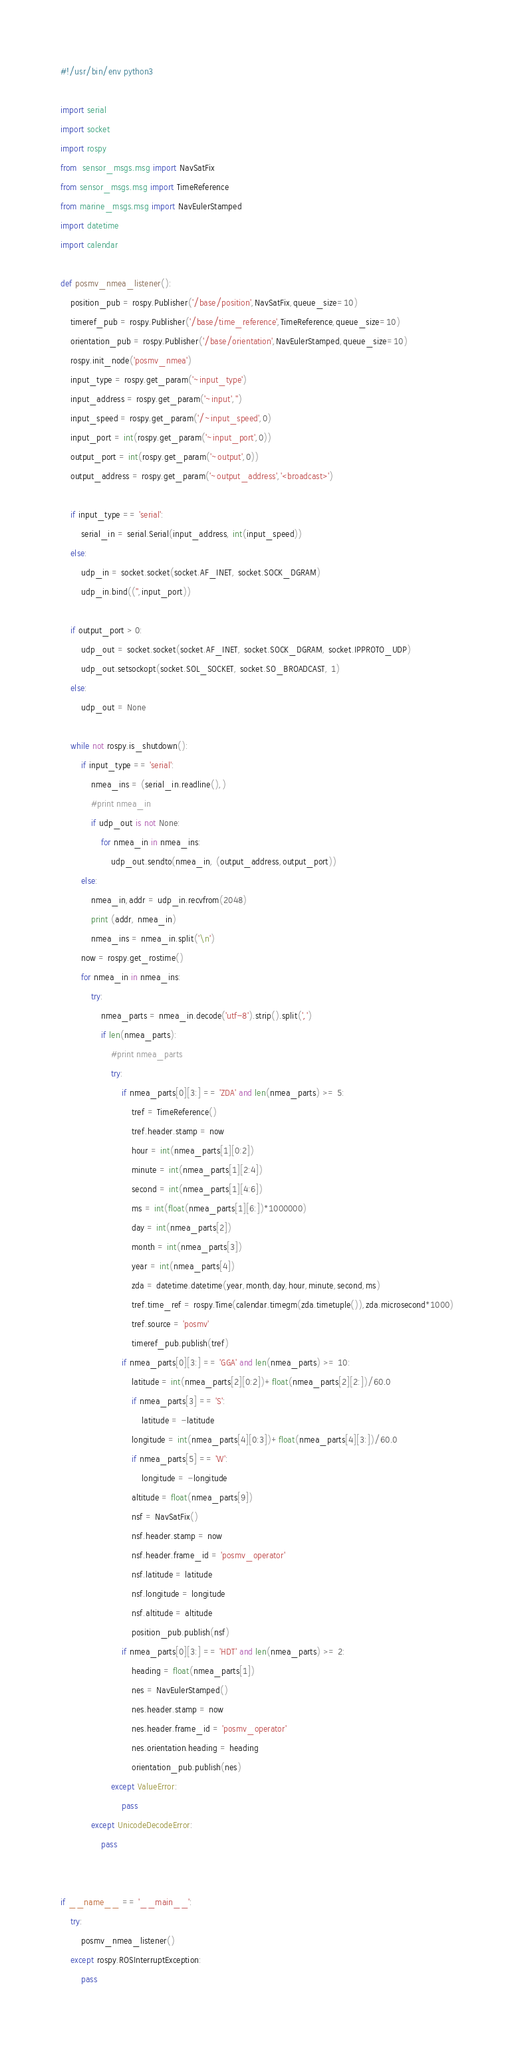Convert code to text. <code><loc_0><loc_0><loc_500><loc_500><_Python_>#!/usr/bin/env python3

import serial
import socket
import rospy
from  sensor_msgs.msg import NavSatFix
from sensor_msgs.msg import TimeReference
from marine_msgs.msg import NavEulerStamped
import datetime
import calendar

def posmv_nmea_listener():
    position_pub = rospy.Publisher('/base/position',NavSatFix,queue_size=10)
    timeref_pub = rospy.Publisher('/base/time_reference',TimeReference,queue_size=10)
    orientation_pub = rospy.Publisher('/base/orientation',NavEulerStamped,queue_size=10)
    rospy.init_node('posmv_nmea')
    input_type = rospy.get_param('~input_type')
    input_address = rospy.get_param('~input','')
    input_speed = rospy.get_param('/~input_speed',0)
    input_port = int(rospy.get_param('~input_port',0))
    output_port = int(rospy.get_param('~output',0))
    output_address = rospy.get_param('~output_address','<broadcast>')
    
    if input_type == 'serial':
        serial_in = serial.Serial(input_address, int(input_speed))
    else:
        udp_in = socket.socket(socket.AF_INET, socket.SOCK_DGRAM)
        udp_in.bind(('',input_port))
    
    if output_port > 0:
        udp_out = socket.socket(socket.AF_INET, socket.SOCK_DGRAM, socket.IPPROTO_UDP)
        udp_out.setsockopt(socket.SOL_SOCKET, socket.SO_BROADCAST, 1)
    else:
        udp_out = None
            
    while not rospy.is_shutdown():
        if input_type == 'serial':
            nmea_ins = (serial_in.readline(),)
            #print nmea_in
            if udp_out is not None:
                for nmea_in in nmea_ins:
                    udp_out.sendto(nmea_in, (output_address,output_port))
        else:
            nmea_in,addr = udp_in.recvfrom(2048)
            print (addr, nmea_in)
            nmea_ins = nmea_in.split('\n')
        now = rospy.get_rostime()
        for nmea_in in nmea_ins:
            try:
                nmea_parts = nmea_in.decode('utf-8').strip().split(',')
                if len(nmea_parts):
                    #print nmea_parts
                    try:
                        if nmea_parts[0][3:] == 'ZDA' and len(nmea_parts) >= 5:
                            tref = TimeReference()
                            tref.header.stamp = now
                            hour = int(nmea_parts[1][0:2])
                            minute = int(nmea_parts[1][2:4])
                            second = int(nmea_parts[1][4:6])
                            ms = int(float(nmea_parts[1][6:])*1000000)
                            day = int(nmea_parts[2])
                            month = int(nmea_parts[3])
                            year = int(nmea_parts[4])
                            zda = datetime.datetime(year,month,day,hour,minute,second,ms)
                            tref.time_ref = rospy.Time(calendar.timegm(zda.timetuple()),zda.microsecond*1000)
                            tref.source = 'posmv'
                            timeref_pub.publish(tref)
                        if nmea_parts[0][3:] == 'GGA' and len(nmea_parts) >= 10:
                            latitude = int(nmea_parts[2][0:2])+float(nmea_parts[2][2:])/60.0
                            if nmea_parts[3] == 'S':
                                latitude = -latitude
                            longitude = int(nmea_parts[4][0:3])+float(nmea_parts[4][3:])/60.0
                            if nmea_parts[5] == 'W':
                                longitude = -longitude
                            altitude = float(nmea_parts[9])
                            nsf = NavSatFix()
                            nsf.header.stamp = now
                            nsf.header.frame_id = 'posmv_operator'
                            nsf.latitude = latitude
                            nsf.longitude = longitude
                            nsf.altitude = altitude
                            position_pub.publish(nsf)
                        if nmea_parts[0][3:] == 'HDT' and len(nmea_parts) >= 2:
                            heading = float(nmea_parts[1])
                            nes = NavEulerStamped()
                            nes.header.stamp = now
                            nes.header.frame_id = 'posmv_operator'
                            nes.orientation.heading = heading
                            orientation_pub.publish(nes)
                    except ValueError:
                        pass
            except UnicodeDecodeError:
                pass


if __name__ == '__main__':
    try:
        posmv_nmea_listener()
    except rospy.ROSInterruptException:
        pass


</code> 